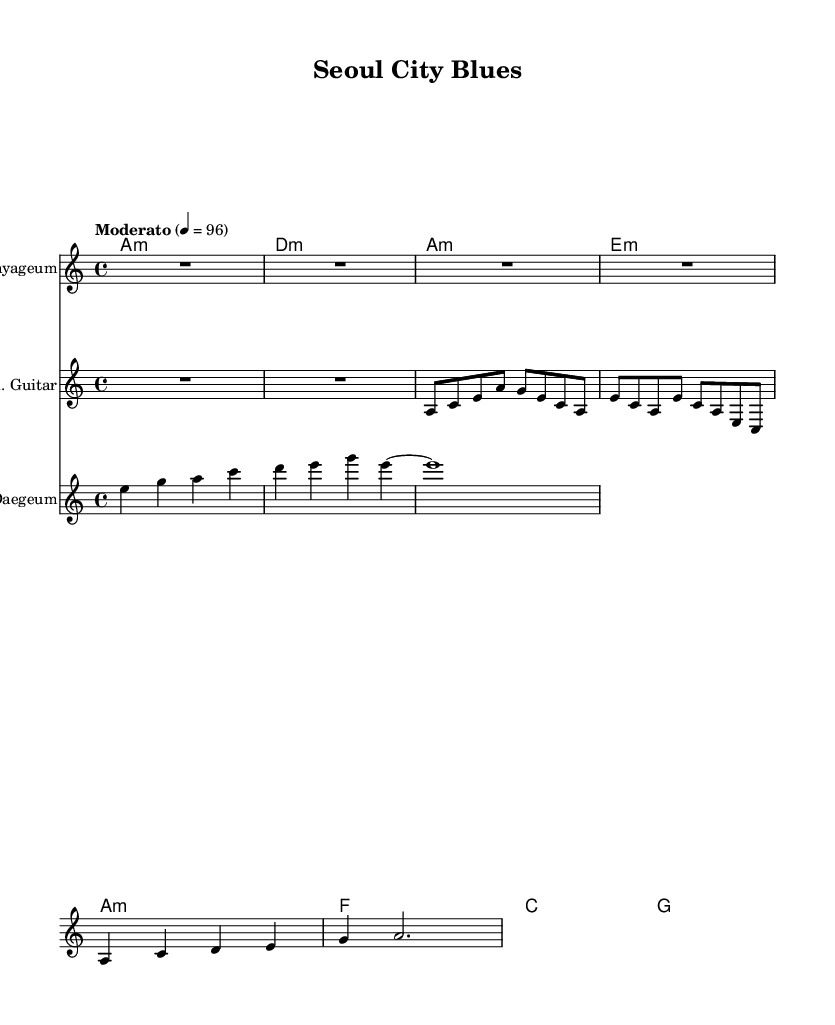What is the key signature of this music? The key signature indicates that there are no sharps or flats, which means it is in A minor. This is determined by noting the absence of accidentals on the staff, and the presence of the note A, which serves as the tonic in A minor.
Answer: A minor What is the time signature of this music? The time signature is indicated at the beginning of the score, showing 4/4. This means there are four beats in a measure and the quarter note gets one beat. This can be confirmed by looking at the notational structure presented in each measure.
Answer: 4/4 What is the tempo marking for this piece? The tempo marking is found at the beginning of the score and is indicated as "Moderato" with a metronome marking of 96. This specifies a moderate pace, providing a clear directive for performing the piece.
Answer: Moderato, 96 How many measures are in the Gayageum intro? Counting the measures in the Gayageum intro section, there are a total of 2 measures present. This is observed by looking at the musical notation where each distinct grouping of notes or rests indicates the beginning or end of a measure.
Answer: 2 Which instrument plays the chorus? The Daegeum is the instrument designated to play the chorus section, as indicated by the label above the staff. This label specifies the instrument for the corresponding part, clarifying its role within the ensemble.
Answer: Daegeum What type of chords are used in the harmony section? The harmony section contains minor and major chords, specifically A minor, D minor, and E minor, accompanied by F and G major chords. This is determined by analyzing the chord symbols above the staff and recognizing their respective qualities.
Answer: Minor and major chords 